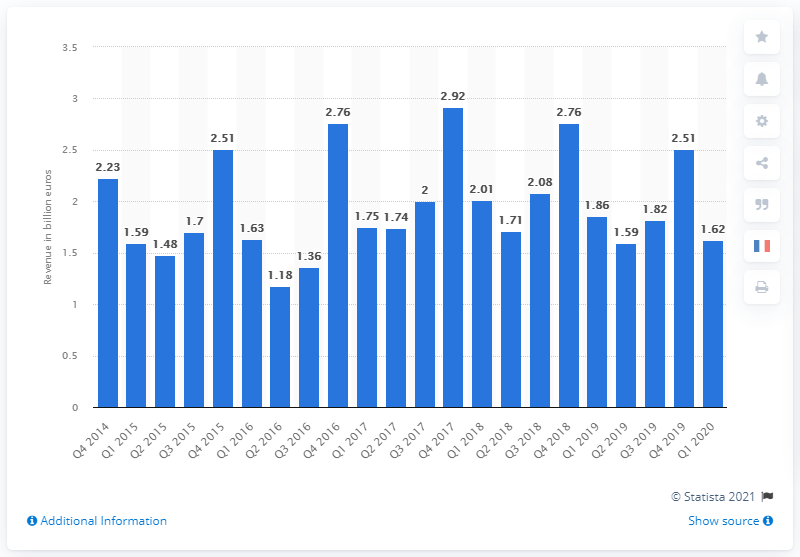Mention a couple of crucial points in this snapshot. In the first quarter of 2020, the revenue generated from telecommunications was 1.62... 